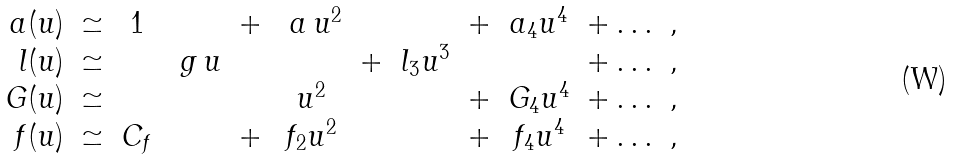Convert formula to latex. <formula><loc_0><loc_0><loc_500><loc_500>\begin{array} { r c c c c c c c c c c } a ( u ) & \simeq & 1 & & + & \ a \, u ^ { 2 } & & & + & a _ { 4 } u ^ { 4 } & + \dots \ , \\ l ( u ) & \simeq & & \ g \, u & & & + & l _ { 3 } u ^ { 3 } & & & + \dots \ , \\ G ( u ) & \simeq & & & & u ^ { 2 } & & & + & G _ { 4 } u ^ { 4 } & + \dots \ , \\ f ( u ) & \simeq & C _ { f } & & + & f _ { 2 } u ^ { 2 } & & & + & f _ { 4 } u ^ { 4 } & + \dots \ , \end{array}</formula> 